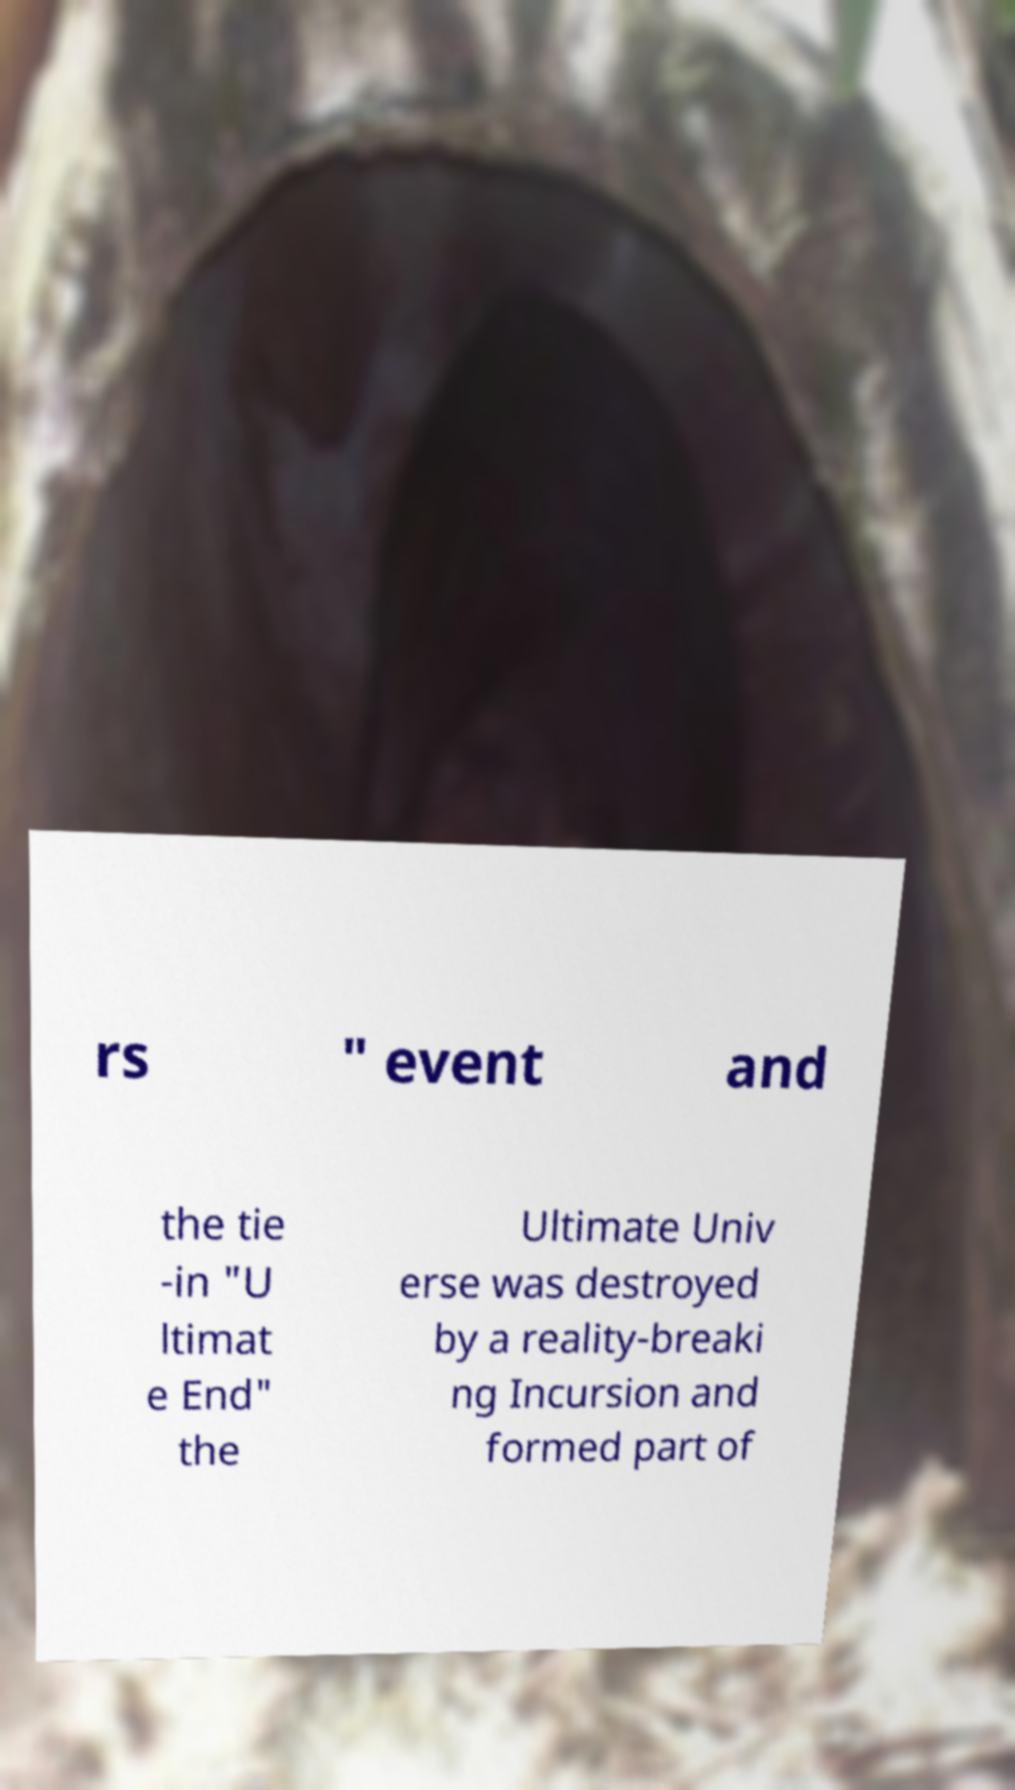Please read and relay the text visible in this image. What does it say? rs " event and the tie -in "U ltimat e End" the Ultimate Univ erse was destroyed by a reality-breaki ng Incursion and formed part of 